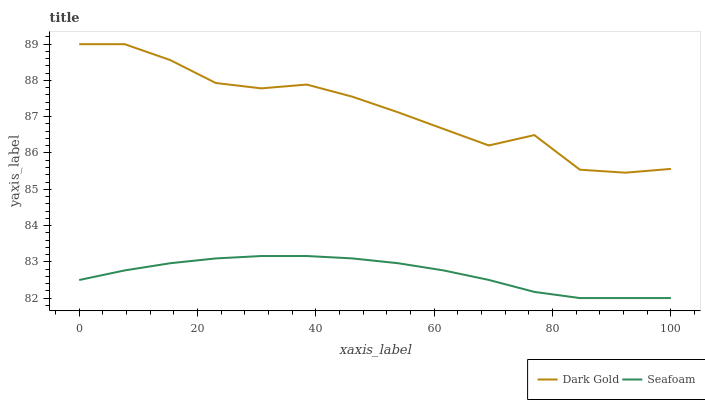Does Seafoam have the minimum area under the curve?
Answer yes or no. Yes. Does Dark Gold have the maximum area under the curve?
Answer yes or no. Yes. Does Dark Gold have the minimum area under the curve?
Answer yes or no. No. Is Seafoam the smoothest?
Answer yes or no. Yes. Is Dark Gold the roughest?
Answer yes or no. Yes. Is Dark Gold the smoothest?
Answer yes or no. No. Does Seafoam have the lowest value?
Answer yes or no. Yes. Does Dark Gold have the lowest value?
Answer yes or no. No. Does Dark Gold have the highest value?
Answer yes or no. Yes. Is Seafoam less than Dark Gold?
Answer yes or no. Yes. Is Dark Gold greater than Seafoam?
Answer yes or no. Yes. Does Seafoam intersect Dark Gold?
Answer yes or no. No. 